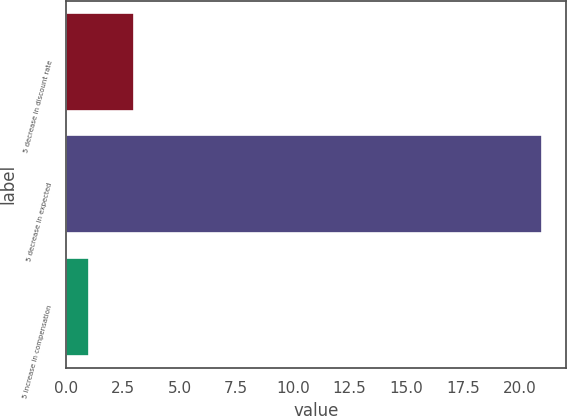Convert chart. <chart><loc_0><loc_0><loc_500><loc_500><bar_chart><fcel>5 decrease in discount rate<fcel>5 decrease in expected<fcel>5 increase in compensation<nl><fcel>3<fcel>21<fcel>1<nl></chart> 